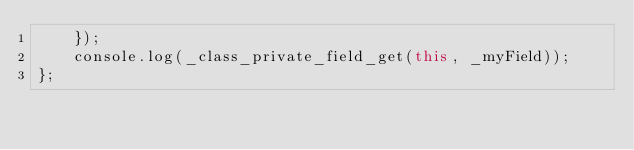Convert code to text. <code><loc_0><loc_0><loc_500><loc_500><_JavaScript_>    });
    console.log(_class_private_field_get(this, _myField));
};
</code> 